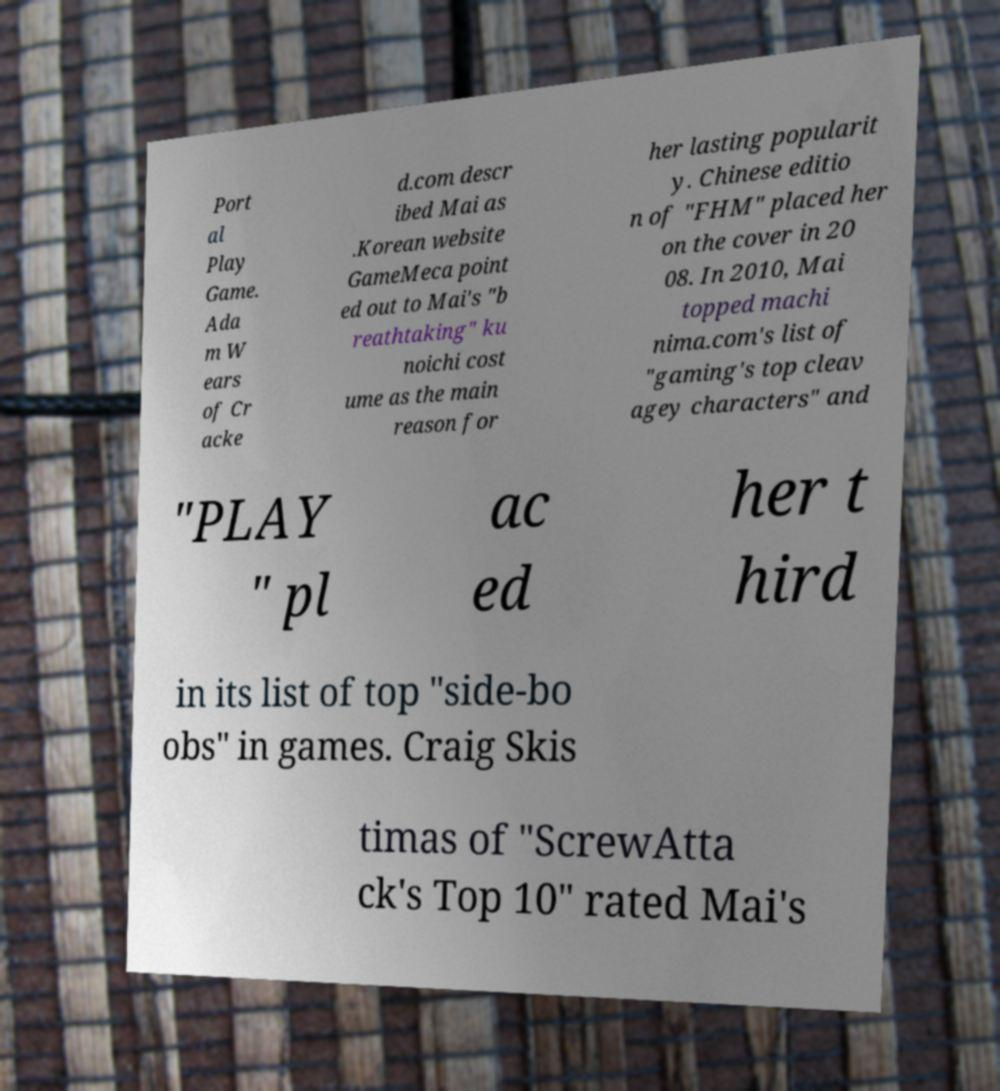Could you assist in decoding the text presented in this image and type it out clearly? Port al Play Game. Ada m W ears of Cr acke d.com descr ibed Mai as .Korean website GameMeca point ed out to Mai's "b reathtaking" ku noichi cost ume as the main reason for her lasting popularit y. Chinese editio n of "FHM" placed her on the cover in 20 08. In 2010, Mai topped machi nima.com's list of "gaming's top cleav agey characters" and "PLAY " pl ac ed her t hird in its list of top "side-bo obs" in games. Craig Skis timas of "ScrewAtta ck's Top 10" rated Mai's 